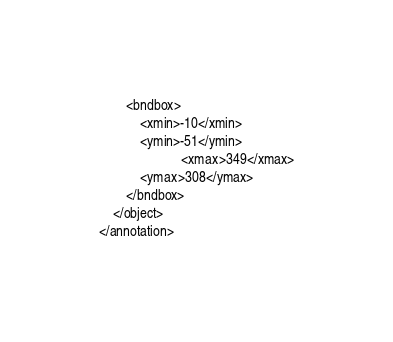Convert code to text. <code><loc_0><loc_0><loc_500><loc_500><_XML_>		<bndbox>
			<xmin>-10</xmin>
			<ymin>-51</ymin>
                        <xmax>349</xmax>
			<ymax>308</ymax>
		</bndbox>
	</object>
</annotation>
</code> 